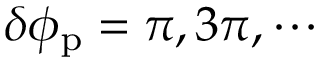<formula> <loc_0><loc_0><loc_500><loc_500>\delta \phi _ { p } = \pi , 3 \pi , \cdots</formula> 